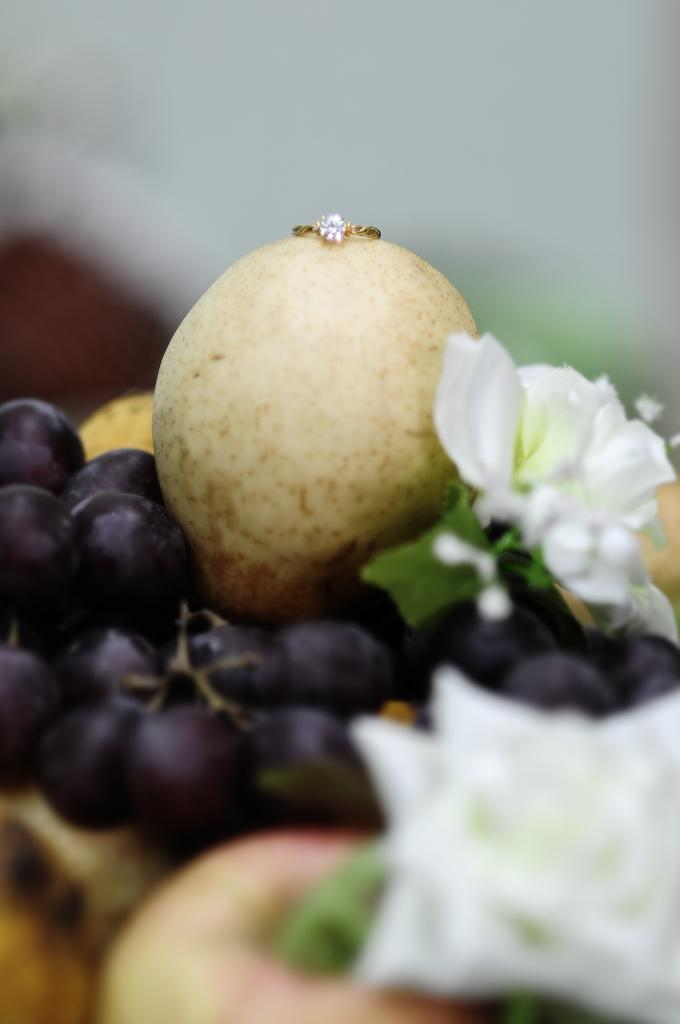What type of grapes can be seen in the image? There are black color grapes in the image. What other objects or elements are present in the image? There are white color flowers, a ring, and a wall in the image. How would you describe the background of the image? The background of the image is blurred. What type of insect can be seen crawling on the sand in the image? There is no sand or insect present in the image. What reward is being given to the person in the image? There is no person or reward present in the image. 